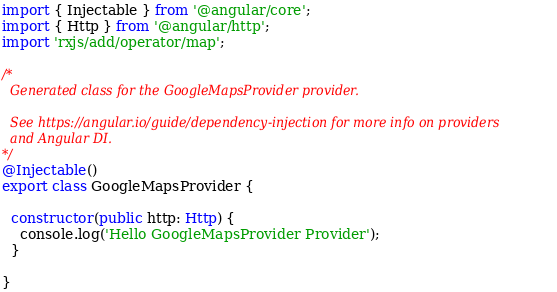Convert code to text. <code><loc_0><loc_0><loc_500><loc_500><_TypeScript_>import { Injectable } from '@angular/core';
import { Http } from '@angular/http';
import 'rxjs/add/operator/map';

/*
  Generated class for the GoogleMapsProvider provider.

  See https://angular.io/guide/dependency-injection for more info on providers
  and Angular DI.
*/
@Injectable()
export class GoogleMapsProvider {

  constructor(public http: Http) {
    console.log('Hello GoogleMapsProvider Provider');
  }

}
</code> 